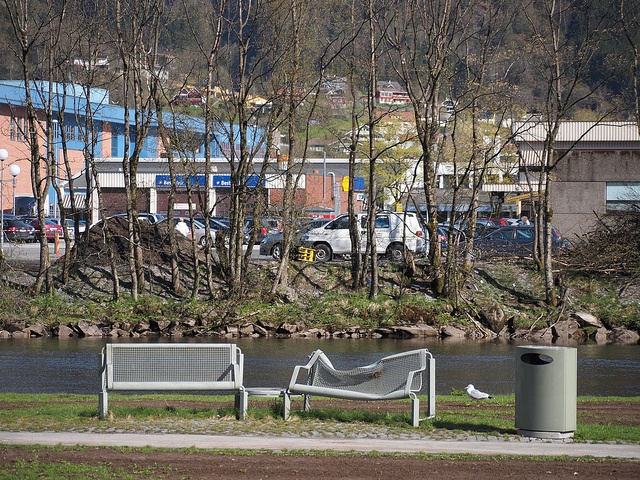Describe the objects in this image and their specific colors. I can see bench in gray, darkgray, lightgray, and black tones, bench in gray, darkgray, lightgray, and black tones, car in gray, lightgray, darkgray, and black tones, car in gray, navy, black, and darkblue tones, and car in gray, black, and darkgray tones in this image. 